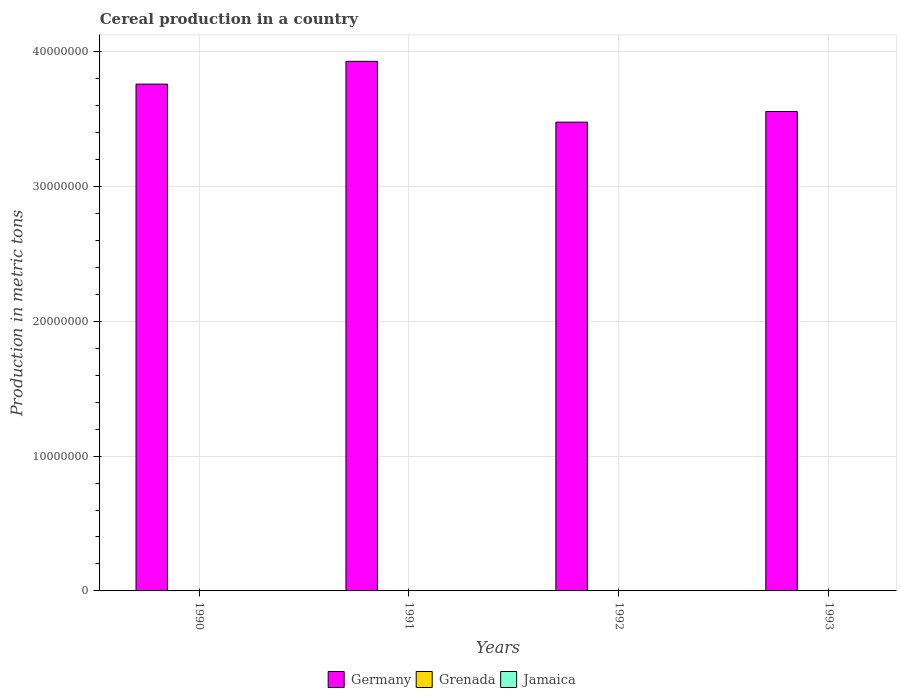How many different coloured bars are there?
Your response must be concise. 3. Are the number of bars per tick equal to the number of legend labels?
Ensure brevity in your answer.  Yes. What is the label of the 2nd group of bars from the left?
Make the answer very short. 1991. In how many cases, is the number of bars for a given year not equal to the number of legend labels?
Ensure brevity in your answer.  0. What is the total cereal production in Jamaica in 1990?
Your answer should be very brief. 2381. Across all years, what is the maximum total cereal production in Germany?
Ensure brevity in your answer.  3.93e+07. Across all years, what is the minimum total cereal production in Grenada?
Provide a short and direct response. 258. In which year was the total cereal production in Jamaica maximum?
Provide a succinct answer. 1992. In which year was the total cereal production in Germany minimum?
Make the answer very short. 1992. What is the total total cereal production in Grenada in the graph?
Make the answer very short. 1276. What is the difference between the total cereal production in Germany in 1992 and that in 1993?
Your answer should be compact. -7.91e+05. What is the difference between the total cereal production in Jamaica in 1993 and the total cereal production in Germany in 1990?
Provide a succinct answer. -3.76e+07. What is the average total cereal production in Germany per year?
Offer a very short reply. 3.68e+07. In the year 1990, what is the difference between the total cereal production in Germany and total cereal production in Jamaica?
Provide a succinct answer. 3.76e+07. What is the ratio of the total cereal production in Jamaica in 1990 to that in 1992?
Offer a terse response. 0.55. Is the total cereal production in Germany in 1990 less than that in 1993?
Offer a terse response. No. What is the difference between the highest and the second highest total cereal production in Jamaica?
Your response must be concise. 770. What is the difference between the highest and the lowest total cereal production in Germany?
Your answer should be compact. 4.51e+06. In how many years, is the total cereal production in Grenada greater than the average total cereal production in Grenada taken over all years?
Ensure brevity in your answer.  2. Is the sum of the total cereal production in Jamaica in 1992 and 1993 greater than the maximum total cereal production in Grenada across all years?
Give a very brief answer. Yes. What does the 1st bar from the left in 1993 represents?
Offer a terse response. Germany. What does the 3rd bar from the right in 1992 represents?
Make the answer very short. Germany. Is it the case that in every year, the sum of the total cereal production in Grenada and total cereal production in Jamaica is greater than the total cereal production in Germany?
Offer a very short reply. No. How many bars are there?
Your answer should be very brief. 12. Are all the bars in the graph horizontal?
Your response must be concise. No. How many years are there in the graph?
Offer a very short reply. 4. Does the graph contain grids?
Keep it short and to the point. Yes. Where does the legend appear in the graph?
Provide a short and direct response. Bottom center. How many legend labels are there?
Your answer should be compact. 3. How are the legend labels stacked?
Make the answer very short. Horizontal. What is the title of the graph?
Keep it short and to the point. Cereal production in a country. Does "New Zealand" appear as one of the legend labels in the graph?
Give a very brief answer. No. What is the label or title of the X-axis?
Give a very brief answer. Years. What is the label or title of the Y-axis?
Offer a very short reply. Production in metric tons. What is the Production in metric tons in Germany in 1990?
Provide a succinct answer. 3.76e+07. What is the Production in metric tons in Grenada in 1990?
Keep it short and to the point. 258. What is the Production in metric tons in Jamaica in 1990?
Offer a very short reply. 2381. What is the Production in metric tons in Germany in 1991?
Keep it short and to the point. 3.93e+07. What is the Production in metric tons in Grenada in 1991?
Give a very brief answer. 295. What is the Production in metric tons in Jamaica in 1991?
Provide a short and direct response. 3466. What is the Production in metric tons in Germany in 1992?
Offer a very short reply. 3.48e+07. What is the Production in metric tons of Grenada in 1992?
Provide a succinct answer. 337. What is the Production in metric tons in Jamaica in 1992?
Your answer should be very brief. 4334. What is the Production in metric tons in Germany in 1993?
Your answer should be compact. 3.55e+07. What is the Production in metric tons of Grenada in 1993?
Offer a very short reply. 386. What is the Production in metric tons of Jamaica in 1993?
Your answer should be very brief. 3564. Across all years, what is the maximum Production in metric tons of Germany?
Ensure brevity in your answer.  3.93e+07. Across all years, what is the maximum Production in metric tons of Grenada?
Provide a short and direct response. 386. Across all years, what is the maximum Production in metric tons of Jamaica?
Your response must be concise. 4334. Across all years, what is the minimum Production in metric tons of Germany?
Ensure brevity in your answer.  3.48e+07. Across all years, what is the minimum Production in metric tons in Grenada?
Offer a very short reply. 258. Across all years, what is the minimum Production in metric tons of Jamaica?
Offer a very short reply. 2381. What is the total Production in metric tons of Germany in the graph?
Keep it short and to the point. 1.47e+08. What is the total Production in metric tons of Grenada in the graph?
Offer a very short reply. 1276. What is the total Production in metric tons of Jamaica in the graph?
Provide a succinct answer. 1.37e+04. What is the difference between the Production in metric tons in Germany in 1990 and that in 1991?
Provide a short and direct response. -1.69e+06. What is the difference between the Production in metric tons in Grenada in 1990 and that in 1991?
Provide a succinct answer. -37. What is the difference between the Production in metric tons of Jamaica in 1990 and that in 1991?
Ensure brevity in your answer.  -1085. What is the difference between the Production in metric tons of Germany in 1990 and that in 1992?
Offer a terse response. 2.82e+06. What is the difference between the Production in metric tons in Grenada in 1990 and that in 1992?
Provide a succinct answer. -79. What is the difference between the Production in metric tons of Jamaica in 1990 and that in 1992?
Offer a very short reply. -1953. What is the difference between the Production in metric tons in Germany in 1990 and that in 1993?
Your response must be concise. 2.03e+06. What is the difference between the Production in metric tons in Grenada in 1990 and that in 1993?
Provide a succinct answer. -128. What is the difference between the Production in metric tons of Jamaica in 1990 and that in 1993?
Your answer should be very brief. -1183. What is the difference between the Production in metric tons of Germany in 1991 and that in 1992?
Make the answer very short. 4.51e+06. What is the difference between the Production in metric tons in Grenada in 1991 and that in 1992?
Offer a terse response. -42. What is the difference between the Production in metric tons of Jamaica in 1991 and that in 1992?
Keep it short and to the point. -868. What is the difference between the Production in metric tons in Germany in 1991 and that in 1993?
Your response must be concise. 3.72e+06. What is the difference between the Production in metric tons of Grenada in 1991 and that in 1993?
Offer a terse response. -91. What is the difference between the Production in metric tons in Jamaica in 1991 and that in 1993?
Provide a succinct answer. -98. What is the difference between the Production in metric tons of Germany in 1992 and that in 1993?
Your answer should be very brief. -7.91e+05. What is the difference between the Production in metric tons of Grenada in 1992 and that in 1993?
Make the answer very short. -49. What is the difference between the Production in metric tons in Jamaica in 1992 and that in 1993?
Keep it short and to the point. 770. What is the difference between the Production in metric tons in Germany in 1990 and the Production in metric tons in Grenada in 1991?
Provide a succinct answer. 3.76e+07. What is the difference between the Production in metric tons in Germany in 1990 and the Production in metric tons in Jamaica in 1991?
Provide a short and direct response. 3.76e+07. What is the difference between the Production in metric tons in Grenada in 1990 and the Production in metric tons in Jamaica in 1991?
Your answer should be compact. -3208. What is the difference between the Production in metric tons of Germany in 1990 and the Production in metric tons of Grenada in 1992?
Ensure brevity in your answer.  3.76e+07. What is the difference between the Production in metric tons of Germany in 1990 and the Production in metric tons of Jamaica in 1992?
Provide a short and direct response. 3.76e+07. What is the difference between the Production in metric tons in Grenada in 1990 and the Production in metric tons in Jamaica in 1992?
Provide a succinct answer. -4076. What is the difference between the Production in metric tons of Germany in 1990 and the Production in metric tons of Grenada in 1993?
Your answer should be compact. 3.76e+07. What is the difference between the Production in metric tons in Germany in 1990 and the Production in metric tons in Jamaica in 1993?
Your answer should be very brief. 3.76e+07. What is the difference between the Production in metric tons in Grenada in 1990 and the Production in metric tons in Jamaica in 1993?
Your answer should be compact. -3306. What is the difference between the Production in metric tons of Germany in 1991 and the Production in metric tons of Grenada in 1992?
Keep it short and to the point. 3.93e+07. What is the difference between the Production in metric tons of Germany in 1991 and the Production in metric tons of Jamaica in 1992?
Make the answer very short. 3.93e+07. What is the difference between the Production in metric tons of Grenada in 1991 and the Production in metric tons of Jamaica in 1992?
Give a very brief answer. -4039. What is the difference between the Production in metric tons of Germany in 1991 and the Production in metric tons of Grenada in 1993?
Ensure brevity in your answer.  3.93e+07. What is the difference between the Production in metric tons in Germany in 1991 and the Production in metric tons in Jamaica in 1993?
Your answer should be compact. 3.93e+07. What is the difference between the Production in metric tons in Grenada in 1991 and the Production in metric tons in Jamaica in 1993?
Make the answer very short. -3269. What is the difference between the Production in metric tons in Germany in 1992 and the Production in metric tons in Grenada in 1993?
Your answer should be very brief. 3.48e+07. What is the difference between the Production in metric tons of Germany in 1992 and the Production in metric tons of Jamaica in 1993?
Offer a terse response. 3.48e+07. What is the difference between the Production in metric tons of Grenada in 1992 and the Production in metric tons of Jamaica in 1993?
Offer a very short reply. -3227. What is the average Production in metric tons of Germany per year?
Offer a very short reply. 3.68e+07. What is the average Production in metric tons of Grenada per year?
Provide a succinct answer. 319. What is the average Production in metric tons in Jamaica per year?
Your answer should be compact. 3436.25. In the year 1990, what is the difference between the Production in metric tons in Germany and Production in metric tons in Grenada?
Your response must be concise. 3.76e+07. In the year 1990, what is the difference between the Production in metric tons in Germany and Production in metric tons in Jamaica?
Ensure brevity in your answer.  3.76e+07. In the year 1990, what is the difference between the Production in metric tons of Grenada and Production in metric tons of Jamaica?
Make the answer very short. -2123. In the year 1991, what is the difference between the Production in metric tons of Germany and Production in metric tons of Grenada?
Offer a terse response. 3.93e+07. In the year 1991, what is the difference between the Production in metric tons in Germany and Production in metric tons in Jamaica?
Give a very brief answer. 3.93e+07. In the year 1991, what is the difference between the Production in metric tons in Grenada and Production in metric tons in Jamaica?
Make the answer very short. -3171. In the year 1992, what is the difference between the Production in metric tons of Germany and Production in metric tons of Grenada?
Give a very brief answer. 3.48e+07. In the year 1992, what is the difference between the Production in metric tons of Germany and Production in metric tons of Jamaica?
Make the answer very short. 3.48e+07. In the year 1992, what is the difference between the Production in metric tons of Grenada and Production in metric tons of Jamaica?
Offer a terse response. -3997. In the year 1993, what is the difference between the Production in metric tons of Germany and Production in metric tons of Grenada?
Give a very brief answer. 3.55e+07. In the year 1993, what is the difference between the Production in metric tons in Germany and Production in metric tons in Jamaica?
Keep it short and to the point. 3.55e+07. In the year 1993, what is the difference between the Production in metric tons in Grenada and Production in metric tons in Jamaica?
Offer a very short reply. -3178. What is the ratio of the Production in metric tons of Grenada in 1990 to that in 1991?
Provide a short and direct response. 0.87. What is the ratio of the Production in metric tons in Jamaica in 1990 to that in 1991?
Keep it short and to the point. 0.69. What is the ratio of the Production in metric tons in Germany in 1990 to that in 1992?
Make the answer very short. 1.08. What is the ratio of the Production in metric tons in Grenada in 1990 to that in 1992?
Provide a succinct answer. 0.77. What is the ratio of the Production in metric tons of Jamaica in 1990 to that in 1992?
Give a very brief answer. 0.55. What is the ratio of the Production in metric tons in Germany in 1990 to that in 1993?
Your answer should be compact. 1.06. What is the ratio of the Production in metric tons in Grenada in 1990 to that in 1993?
Your answer should be compact. 0.67. What is the ratio of the Production in metric tons of Jamaica in 1990 to that in 1993?
Your response must be concise. 0.67. What is the ratio of the Production in metric tons of Germany in 1991 to that in 1992?
Provide a short and direct response. 1.13. What is the ratio of the Production in metric tons of Grenada in 1991 to that in 1992?
Your response must be concise. 0.88. What is the ratio of the Production in metric tons in Jamaica in 1991 to that in 1992?
Keep it short and to the point. 0.8. What is the ratio of the Production in metric tons of Germany in 1991 to that in 1993?
Your response must be concise. 1.1. What is the ratio of the Production in metric tons of Grenada in 1991 to that in 1993?
Your response must be concise. 0.76. What is the ratio of the Production in metric tons of Jamaica in 1991 to that in 1993?
Your answer should be compact. 0.97. What is the ratio of the Production in metric tons in Germany in 1992 to that in 1993?
Ensure brevity in your answer.  0.98. What is the ratio of the Production in metric tons of Grenada in 1992 to that in 1993?
Give a very brief answer. 0.87. What is the ratio of the Production in metric tons of Jamaica in 1992 to that in 1993?
Provide a succinct answer. 1.22. What is the difference between the highest and the second highest Production in metric tons of Germany?
Your answer should be compact. 1.69e+06. What is the difference between the highest and the second highest Production in metric tons in Jamaica?
Your answer should be compact. 770. What is the difference between the highest and the lowest Production in metric tons in Germany?
Offer a very short reply. 4.51e+06. What is the difference between the highest and the lowest Production in metric tons of Grenada?
Give a very brief answer. 128. What is the difference between the highest and the lowest Production in metric tons of Jamaica?
Provide a succinct answer. 1953. 